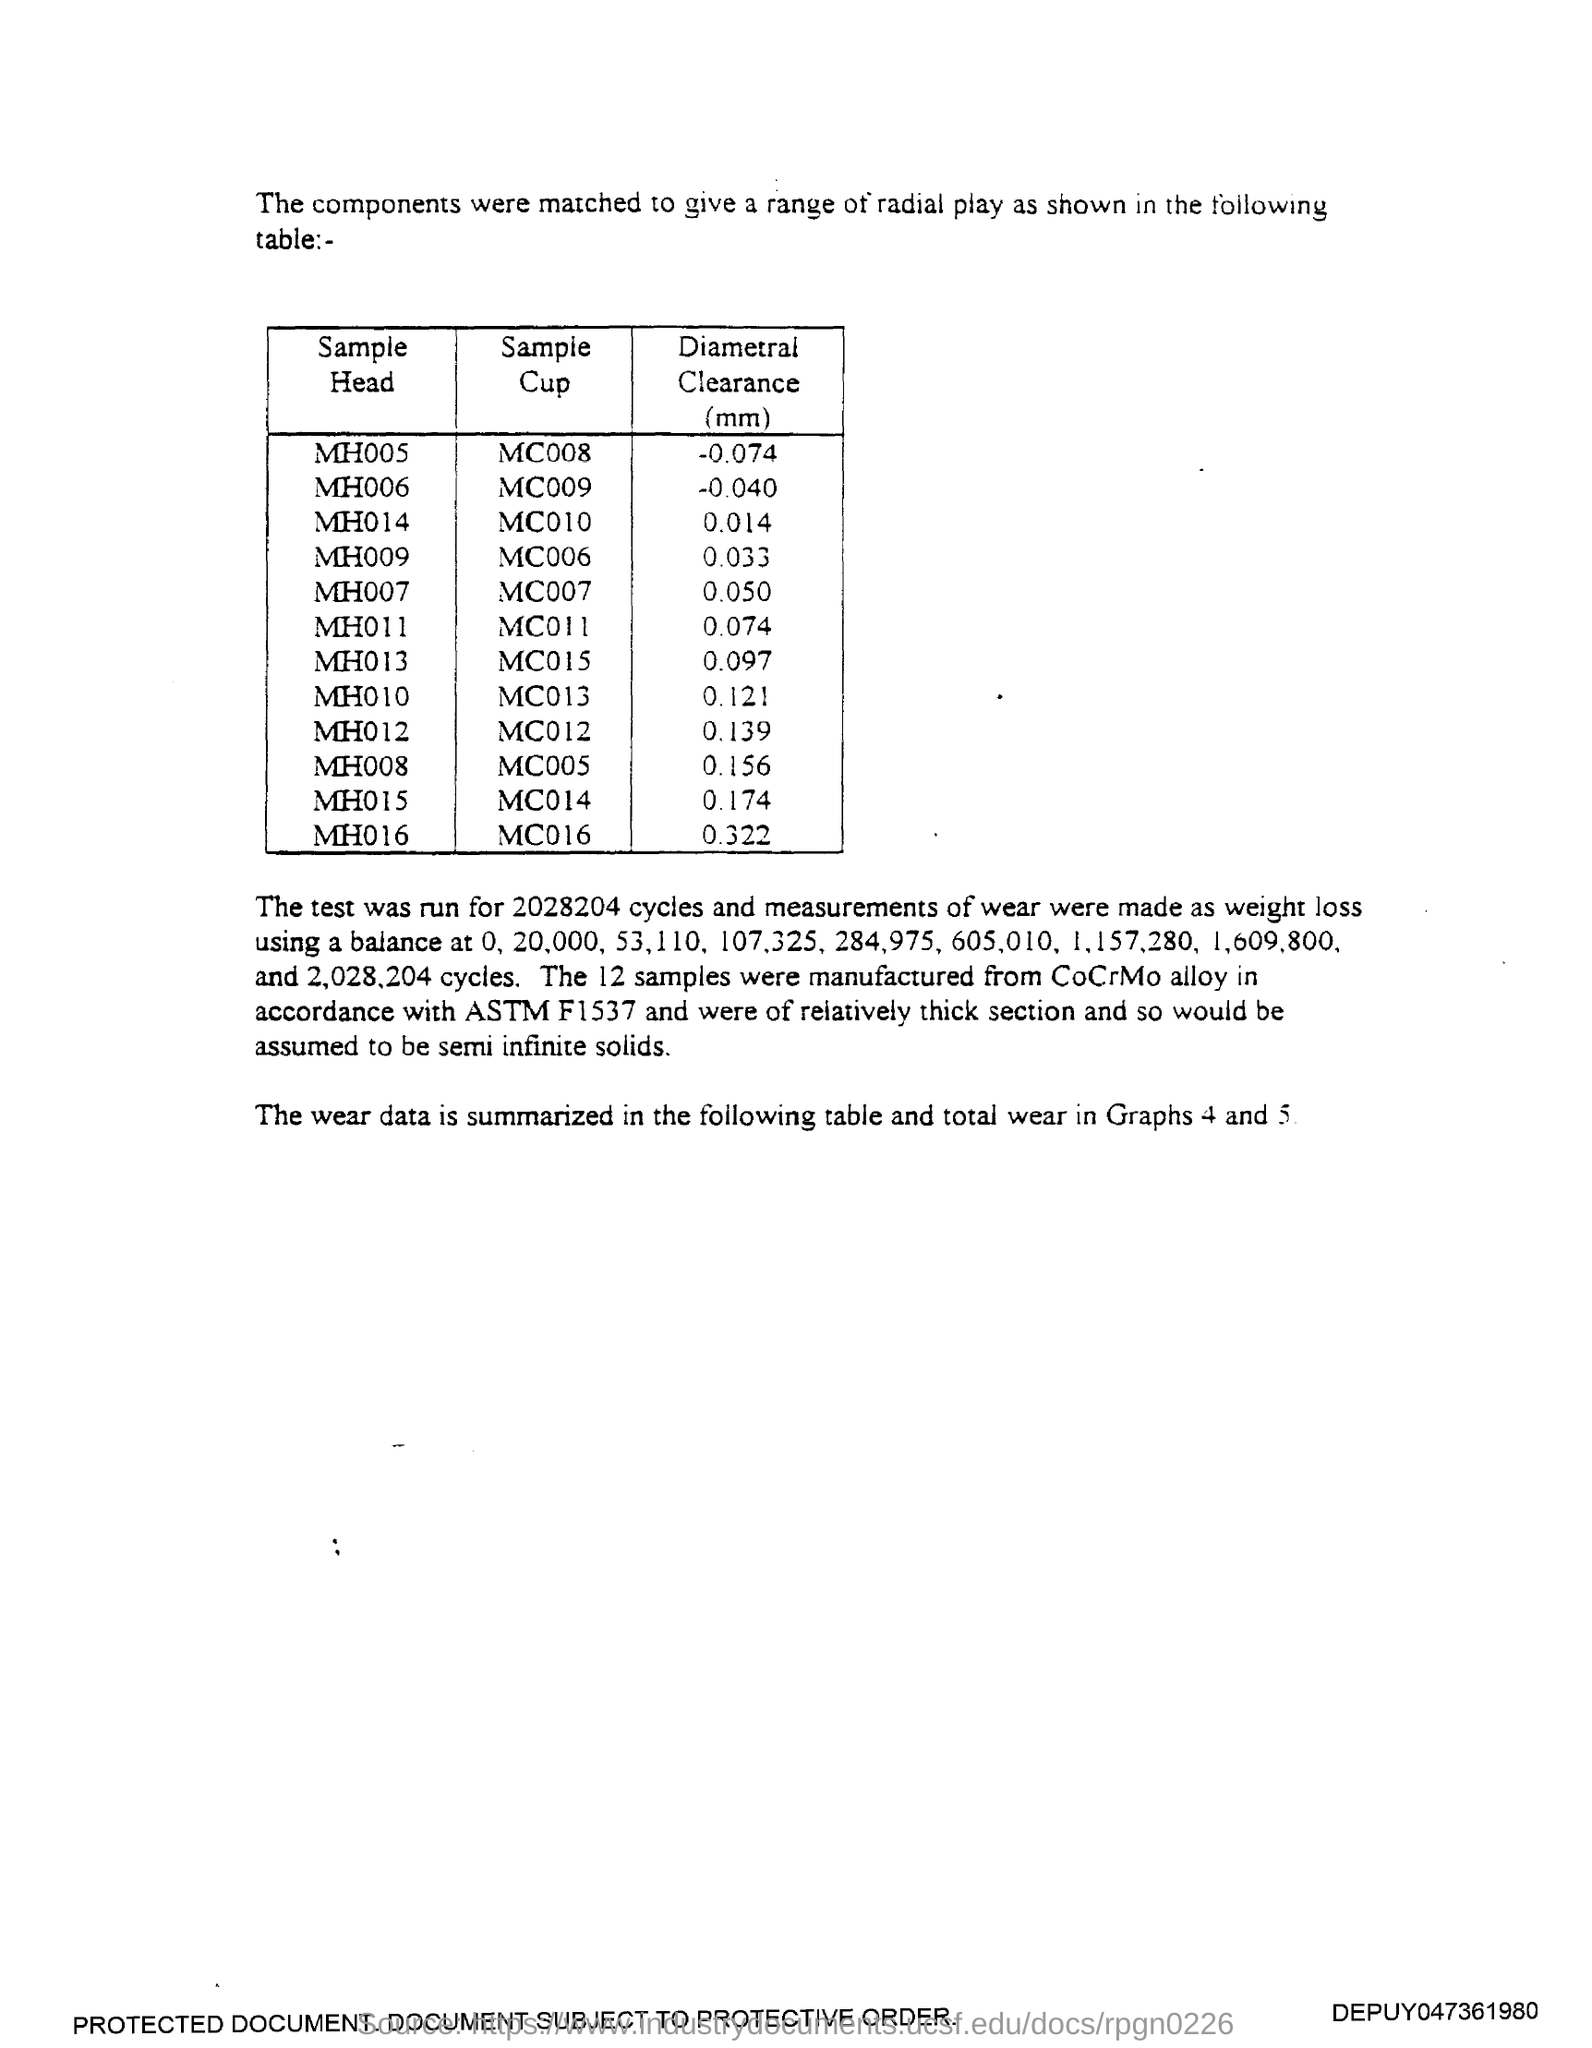What is the Diameter clearance (mm) for Sample head MH005?
Give a very brief answer. -0.074. What is the Diameter clearance (mm) for Sample head MH006?
Your response must be concise. -0.040. What is the Diameter clearance (mm) for Sample head MH014?
Provide a short and direct response. 0.014. What is the Diameter clearance (mm) for Sample head MH009?
Make the answer very short. 0.033. What is the Diameter clearance (mm) for Sample head MH007?
Your answer should be very brief. 0.050. What is the Diameter clearance (mm) for Sample head MH011?
Your response must be concise. 0.074. What is the Diameter clearance (mm) for Sample head MH013?
Provide a short and direct response. 0.097. What is the Diameter clearance (mm) for Sample head MH010?
Provide a short and direct response. 0.121. What is the Diameter clearance (mm) for Sample head MH012?
Provide a succinct answer. 0.139. What is the Diameter clearance (mm) for Sample head MH008?
Provide a short and direct response. 0.156. 